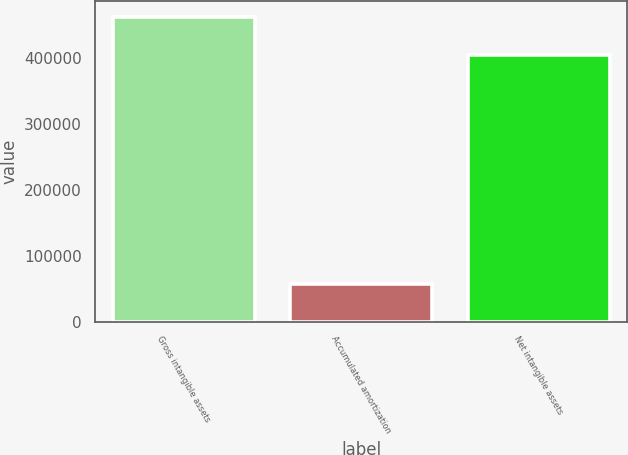<chart> <loc_0><loc_0><loc_500><loc_500><bar_chart><fcel>Gross intangible assets<fcel>Accumulated amortization<fcel>Net intangible assets<nl><fcel>462214<fcel>57496<fcel>404718<nl></chart> 